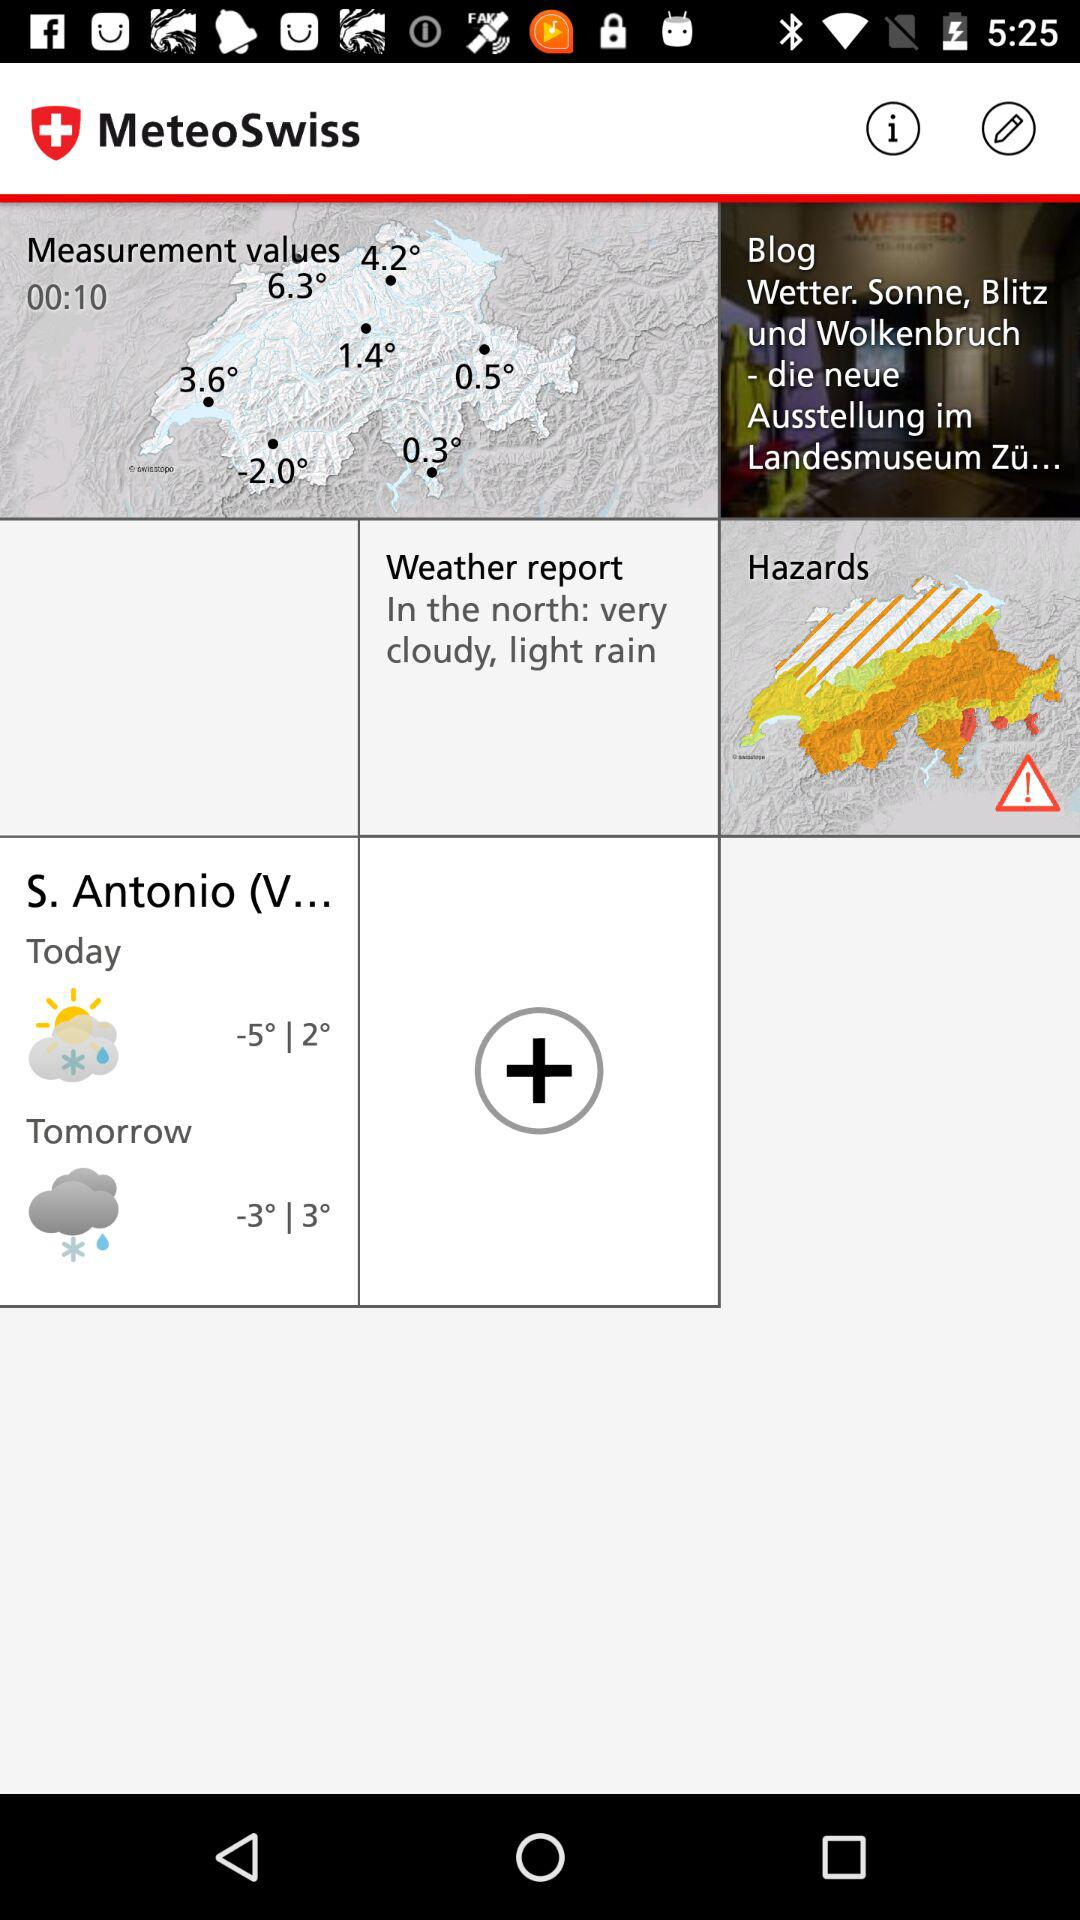What is the temperature for tomorrow? The temperature for tomorrow ranges from -3° to 3°. 